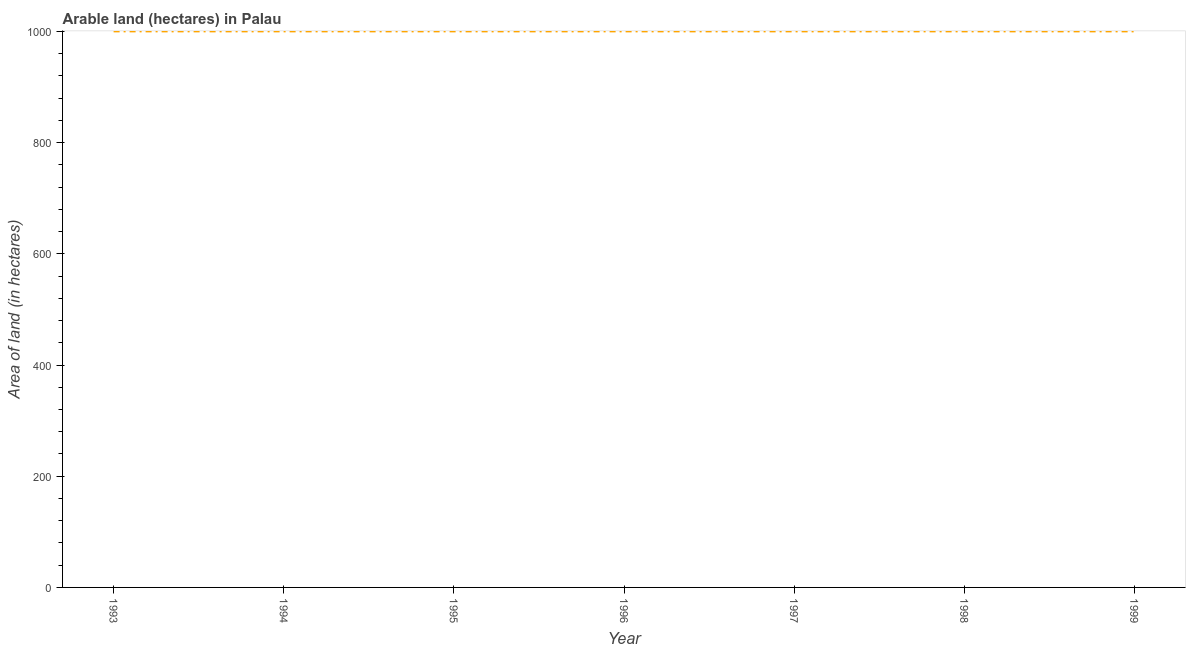What is the area of land in 1999?
Provide a short and direct response. 1000. Across all years, what is the maximum area of land?
Provide a short and direct response. 1000. Across all years, what is the minimum area of land?
Offer a terse response. 1000. In which year was the area of land maximum?
Ensure brevity in your answer.  1993. In which year was the area of land minimum?
Your response must be concise. 1993. What is the sum of the area of land?
Keep it short and to the point. 7000. What is the difference between the area of land in 1996 and 1999?
Offer a terse response. 0. What is the average area of land per year?
Provide a short and direct response. 1000. What is the median area of land?
Keep it short and to the point. 1000. In how many years, is the area of land greater than 320 hectares?
Your answer should be compact. 7. Do a majority of the years between 1998 and 1993 (inclusive) have area of land greater than 520 hectares?
Make the answer very short. Yes. What is the ratio of the area of land in 1993 to that in 1999?
Your response must be concise. 1. Is the area of land in 1996 less than that in 1999?
Keep it short and to the point. No. What is the difference between the highest and the lowest area of land?
Your response must be concise. 0. How many lines are there?
Offer a very short reply. 1. What is the difference between two consecutive major ticks on the Y-axis?
Your response must be concise. 200. Does the graph contain any zero values?
Provide a succinct answer. No. Does the graph contain grids?
Offer a very short reply. No. What is the title of the graph?
Ensure brevity in your answer.  Arable land (hectares) in Palau. What is the label or title of the Y-axis?
Make the answer very short. Area of land (in hectares). What is the Area of land (in hectares) in 1997?
Your response must be concise. 1000. What is the Area of land (in hectares) of 1999?
Offer a terse response. 1000. What is the difference between the Area of land (in hectares) in 1993 and 1999?
Your answer should be compact. 0. What is the difference between the Area of land (in hectares) in 1994 and 1996?
Provide a succinct answer. 0. What is the difference between the Area of land (in hectares) in 1994 and 1997?
Offer a terse response. 0. What is the difference between the Area of land (in hectares) in 1994 and 1998?
Give a very brief answer. 0. What is the difference between the Area of land (in hectares) in 1995 and 1996?
Provide a succinct answer. 0. What is the difference between the Area of land (in hectares) in 1995 and 1998?
Your answer should be very brief. 0. What is the difference between the Area of land (in hectares) in 1995 and 1999?
Offer a terse response. 0. What is the difference between the Area of land (in hectares) in 1996 and 1997?
Offer a terse response. 0. What is the difference between the Area of land (in hectares) in 1996 and 1999?
Provide a succinct answer. 0. What is the difference between the Area of land (in hectares) in 1998 and 1999?
Your answer should be compact. 0. What is the ratio of the Area of land (in hectares) in 1993 to that in 1994?
Ensure brevity in your answer.  1. What is the ratio of the Area of land (in hectares) in 1993 to that in 1997?
Your response must be concise. 1. What is the ratio of the Area of land (in hectares) in 1993 to that in 1998?
Offer a very short reply. 1. What is the ratio of the Area of land (in hectares) in 1993 to that in 1999?
Ensure brevity in your answer.  1. What is the ratio of the Area of land (in hectares) in 1994 to that in 1995?
Make the answer very short. 1. What is the ratio of the Area of land (in hectares) in 1994 to that in 1996?
Your answer should be very brief. 1. What is the ratio of the Area of land (in hectares) in 1994 to that in 1997?
Offer a very short reply. 1. What is the ratio of the Area of land (in hectares) in 1994 to that in 1999?
Offer a very short reply. 1. What is the ratio of the Area of land (in hectares) in 1995 to that in 1999?
Your answer should be very brief. 1. What is the ratio of the Area of land (in hectares) in 1996 to that in 1998?
Your answer should be very brief. 1. What is the ratio of the Area of land (in hectares) in 1998 to that in 1999?
Your answer should be compact. 1. 